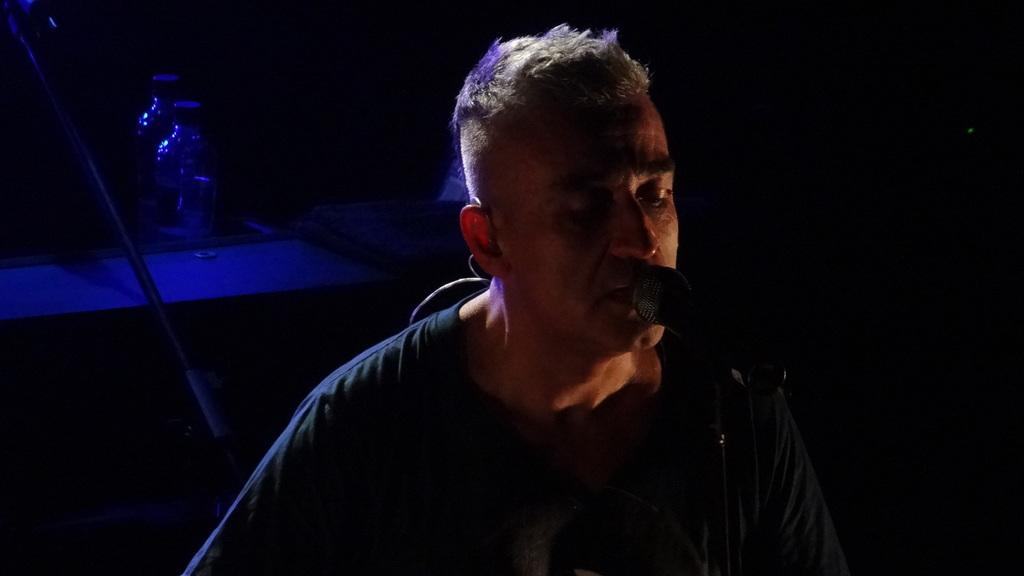Who is the main subject in the image? There is a man in the image. What is the man holding in the image? The man is holding a microphone. What is the man doing with the microphone? The man is speaking. What can be seen in the background of the image? There is a bottle visible in the background of the image. Where is the man's sister in the image? There is no mention of a sister in the image, so we cannot determine her location. 